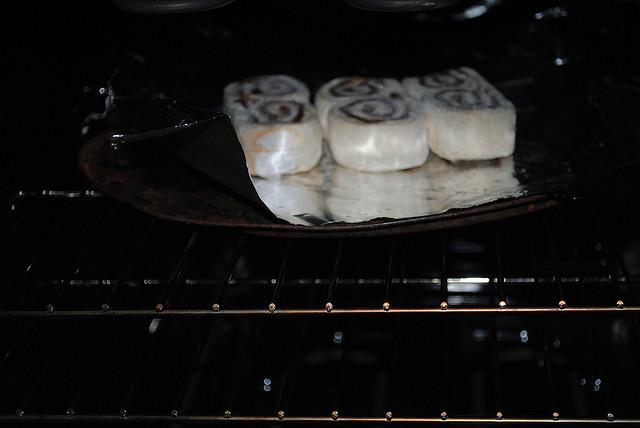Why are the cinnamon buns white? icing 